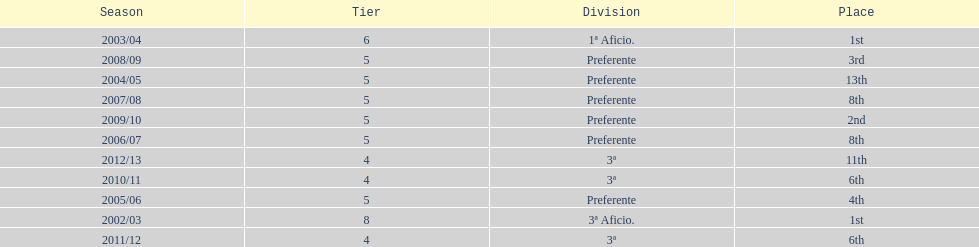Parse the table in full. {'header': ['Season', 'Tier', 'Division', 'Place'], 'rows': [['2003/04', '6', '1ª Aficio.', '1st'], ['2008/09', '5', 'Preferente', '3rd'], ['2004/05', '5', 'Preferente', '13th'], ['2007/08', '5', 'Preferente', '8th'], ['2009/10', '5', 'Preferente', '2nd'], ['2006/07', '5', 'Preferente', '8th'], ['2012/13', '4', '3ª', '11th'], ['2010/11', '4', '3ª', '6th'], ['2005/06', '5', 'Preferente', '4th'], ['2002/03', '8', '3ª Aficio.', '1st'], ['2011/12', '4', '3ª', '6th']]} How many years was the team in the 3 a division? 4. 